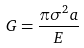<formula> <loc_0><loc_0><loc_500><loc_500>G = \frac { \pi \sigma ^ { 2 } a } { E }</formula> 